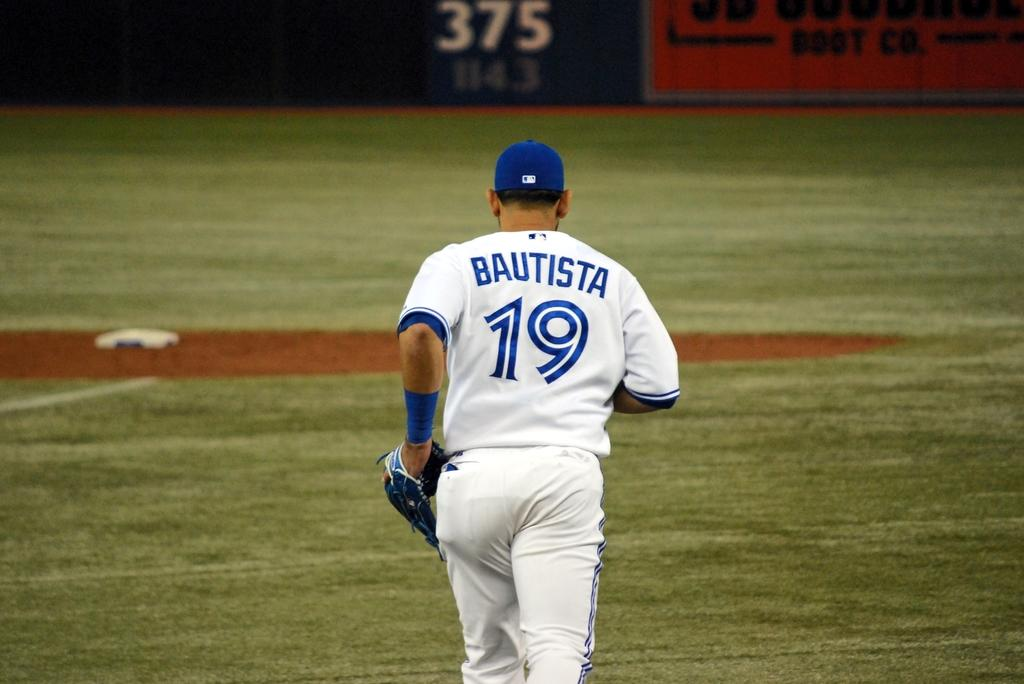What is the person in the image doing? There is a person running in the image. What type of headwear is the person wearing? The person is wearing a cap. What type of handwear is the person wearing? The person is wearing gloves. What type of terrain is visible in the image? There is grass visible in the image. What can be seen in the background of the image? There are hoardings in the background of the image. What type of stamp can be seen on the person's running shoes in the image? There is no stamp visible on the person's running shoes in the image. What type of club is the person holding in the image? There is no club present in the image; the person is running without any visible objects in their hands. 